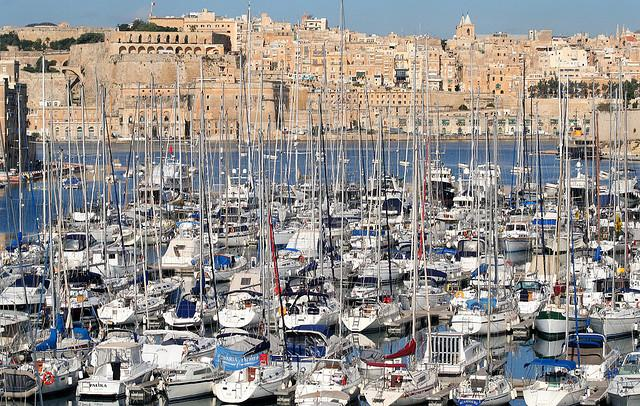What is a group of these abundant items called? Please explain your reasoning. fleet. All the boats grouped together is a fleet. there has to be many boat for a fleet. 